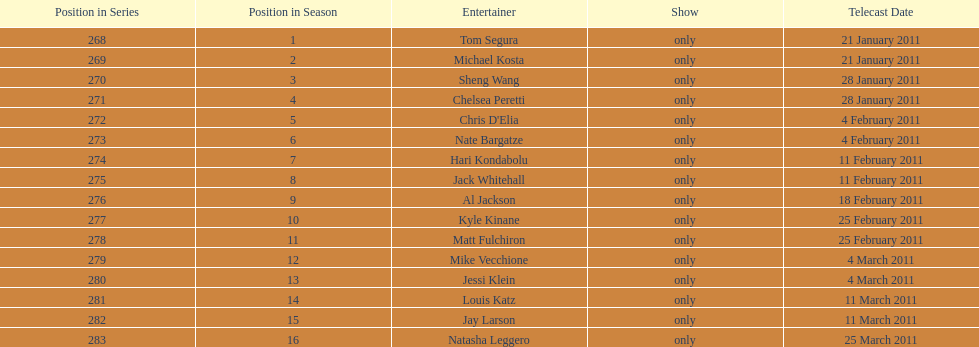How many different performers appeared during this season? 16. 